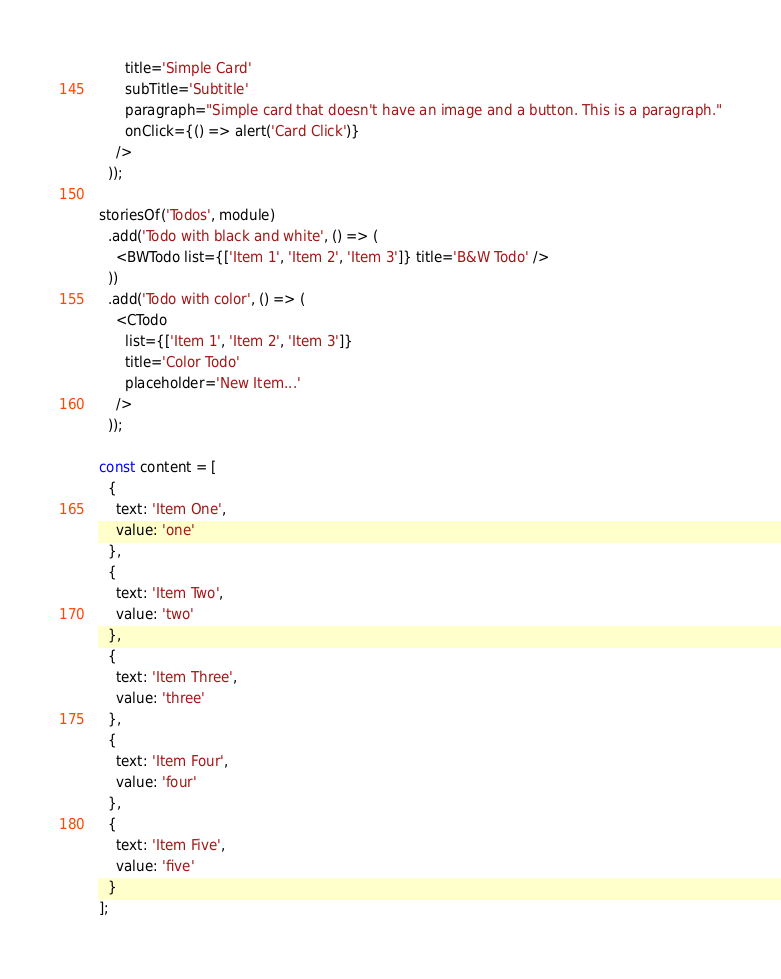Convert code to text. <code><loc_0><loc_0><loc_500><loc_500><_JavaScript_>      title='Simple Card'
      subTitle='Subtitle'
      paragraph="Simple card that doesn't have an image and a button. This is a paragraph."
      onClick={() => alert('Card Click')}
    />
  ));

storiesOf('Todos', module)
  .add('Todo with black and white', () => (
    <BWTodo list={['Item 1', 'Item 2', 'Item 3']} title='B&W Todo' />
  ))
  .add('Todo with color', () => (
    <CTodo
      list={['Item 1', 'Item 2', 'Item 3']}
      title='Color Todo'
      placeholder='New Item...'
    />
  ));

const content = [
  {
    text: 'Item One',
    value: 'one'
  },
  {
    text: 'Item Two',
    value: 'two'
  },
  {
    text: 'Item Three',
    value: 'three'
  },
  {
    text: 'Item Four',
    value: 'four'
  },
  {
    text: 'Item Five',
    value: 'five'
  }
];
</code> 